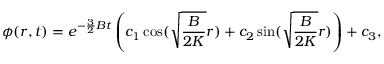<formula> <loc_0><loc_0><loc_500><loc_500>\phi ( r , t ) = e ^ { - \frac { 3 } { 2 } B t } \left ( c _ { 1 } \cos ( \sqrt { \frac { B } { 2 K } } r ) + c _ { 2 } \sin ( \sqrt { \frac { B } { 2 K } } r ) \right ) + c _ { 3 } ,</formula> 